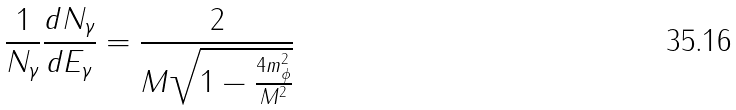<formula> <loc_0><loc_0><loc_500><loc_500>\frac { 1 } { N _ { \gamma } } \frac { d N _ { \gamma } } { d E _ { \gamma } } = \frac { 2 } { M \sqrt { 1 - \frac { 4 m _ { \phi } ^ { 2 } } { M ^ { 2 } } } }</formula> 